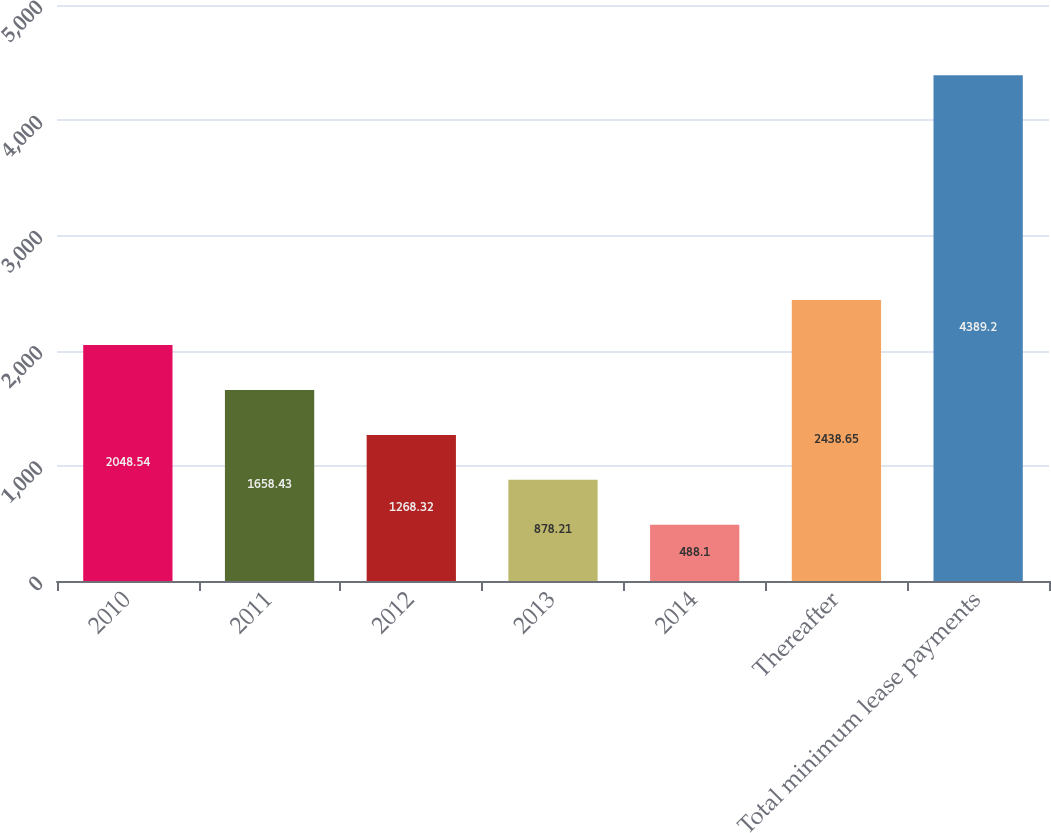<chart> <loc_0><loc_0><loc_500><loc_500><bar_chart><fcel>2010<fcel>2011<fcel>2012<fcel>2013<fcel>2014<fcel>Thereafter<fcel>Total minimum lease payments<nl><fcel>2048.54<fcel>1658.43<fcel>1268.32<fcel>878.21<fcel>488.1<fcel>2438.65<fcel>4389.2<nl></chart> 